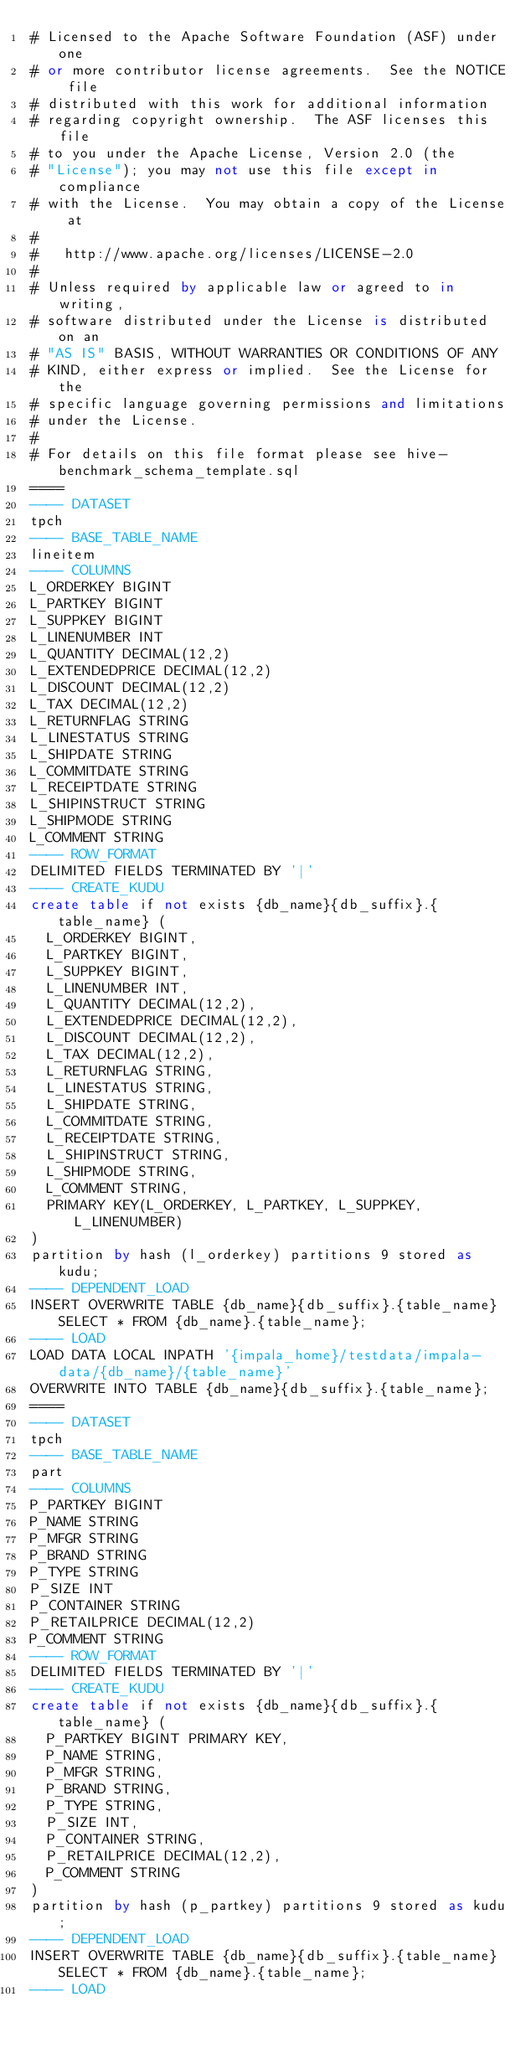Convert code to text. <code><loc_0><loc_0><loc_500><loc_500><_SQL_># Licensed to the Apache Software Foundation (ASF) under one
# or more contributor license agreements.  See the NOTICE file
# distributed with this work for additional information
# regarding copyright ownership.  The ASF licenses this file
# to you under the Apache License, Version 2.0 (the
# "License"); you may not use this file except in compliance
# with the License.  You may obtain a copy of the License at
#
#   http://www.apache.org/licenses/LICENSE-2.0
#
# Unless required by applicable law or agreed to in writing,
# software distributed under the License is distributed on an
# "AS IS" BASIS, WITHOUT WARRANTIES OR CONDITIONS OF ANY
# KIND, either express or implied.  See the License for the
# specific language governing permissions and limitations
# under the License.
#
# For details on this file format please see hive-benchmark_schema_template.sql
====
---- DATASET
tpch
---- BASE_TABLE_NAME
lineitem
---- COLUMNS
L_ORDERKEY BIGINT
L_PARTKEY BIGINT
L_SUPPKEY BIGINT
L_LINENUMBER INT
L_QUANTITY DECIMAL(12,2)
L_EXTENDEDPRICE DECIMAL(12,2)
L_DISCOUNT DECIMAL(12,2)
L_TAX DECIMAL(12,2)
L_RETURNFLAG STRING
L_LINESTATUS STRING
L_SHIPDATE STRING
L_COMMITDATE STRING
L_RECEIPTDATE STRING
L_SHIPINSTRUCT STRING
L_SHIPMODE STRING
L_COMMENT STRING
---- ROW_FORMAT
DELIMITED FIELDS TERMINATED BY '|'
---- CREATE_KUDU
create table if not exists {db_name}{db_suffix}.{table_name} (
  L_ORDERKEY BIGINT,
  L_PARTKEY BIGINT,
  L_SUPPKEY BIGINT,
  L_LINENUMBER INT,
  L_QUANTITY DECIMAL(12,2),
  L_EXTENDEDPRICE DECIMAL(12,2),
  L_DISCOUNT DECIMAL(12,2),
  L_TAX DECIMAL(12,2),
  L_RETURNFLAG STRING,
  L_LINESTATUS STRING,
  L_SHIPDATE STRING,
  L_COMMITDATE STRING,
  L_RECEIPTDATE STRING,
  L_SHIPINSTRUCT STRING,
  L_SHIPMODE STRING,
  L_COMMENT STRING,
  PRIMARY KEY(L_ORDERKEY, L_PARTKEY, L_SUPPKEY, L_LINENUMBER)
)
partition by hash (l_orderkey) partitions 9 stored as kudu;
---- DEPENDENT_LOAD
INSERT OVERWRITE TABLE {db_name}{db_suffix}.{table_name} SELECT * FROM {db_name}.{table_name};
---- LOAD
LOAD DATA LOCAL INPATH '{impala_home}/testdata/impala-data/{db_name}/{table_name}'
OVERWRITE INTO TABLE {db_name}{db_suffix}.{table_name};
====
---- DATASET
tpch
---- BASE_TABLE_NAME
part
---- COLUMNS
P_PARTKEY BIGINT
P_NAME STRING
P_MFGR STRING
P_BRAND STRING
P_TYPE STRING
P_SIZE INT
P_CONTAINER STRING
P_RETAILPRICE DECIMAL(12,2)
P_COMMENT STRING
---- ROW_FORMAT
DELIMITED FIELDS TERMINATED BY '|'
---- CREATE_KUDU
create table if not exists {db_name}{db_suffix}.{table_name} (
  P_PARTKEY BIGINT PRIMARY KEY,
  P_NAME STRING,
  P_MFGR STRING,
  P_BRAND STRING,
  P_TYPE STRING,
  P_SIZE INT,
  P_CONTAINER STRING,
  P_RETAILPRICE DECIMAL(12,2),
  P_COMMENT STRING
)
partition by hash (p_partkey) partitions 9 stored as kudu;
---- DEPENDENT_LOAD
INSERT OVERWRITE TABLE {db_name}{db_suffix}.{table_name} SELECT * FROM {db_name}.{table_name};
---- LOAD</code> 